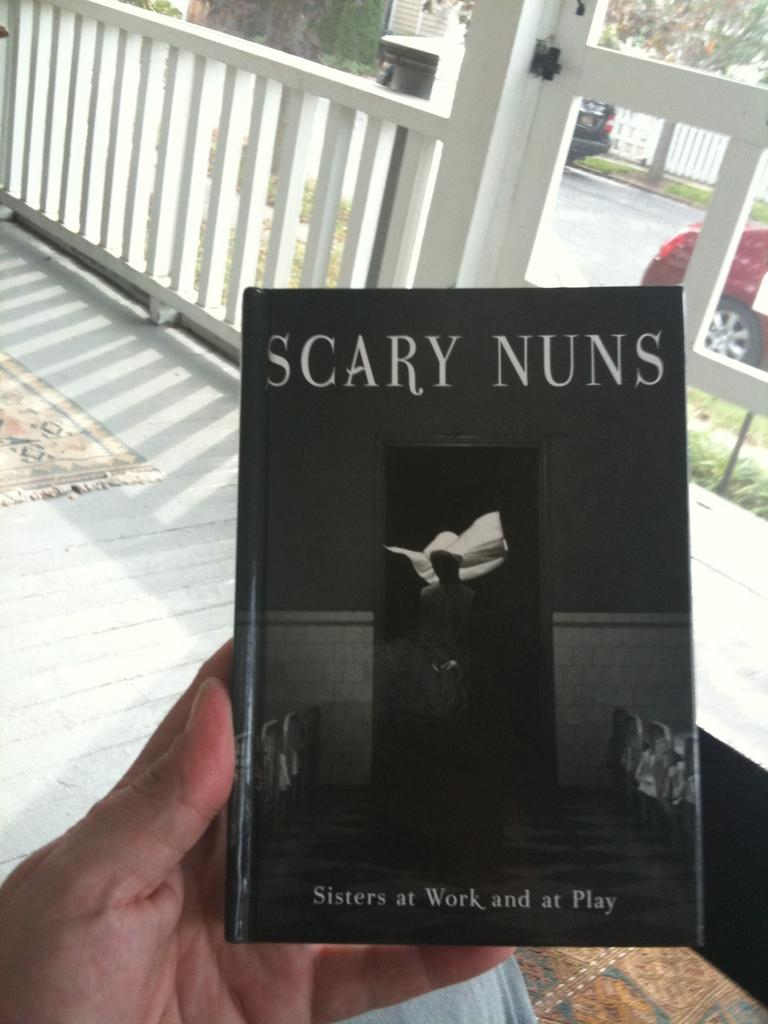Provide a one-sentence caption for the provided image. A hand is holding a booked titled Scary Nuns. 